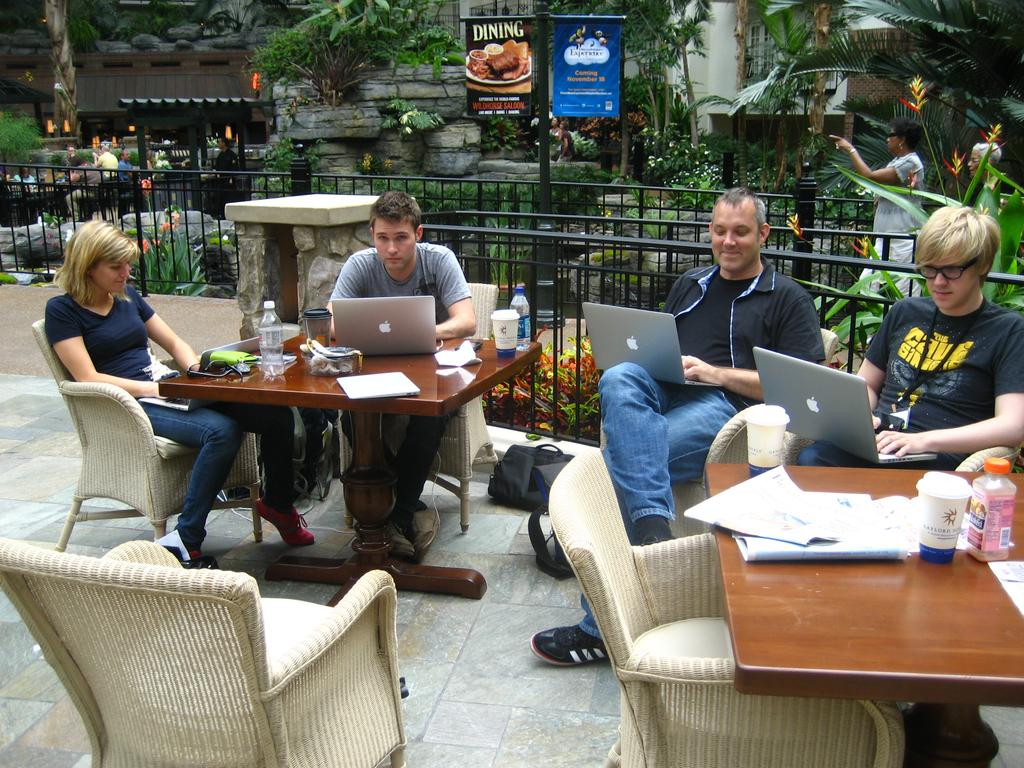How many people are sitting in the image? There are four people sitting on chairs in the image. What objects can be seen on the table? There is a bottle, a book, a cup, and a laptop on the table. What is visible in the background of the image? Trees and a building are visible at the back side of the image. What language are the people speaking in the image? There is no information about the language being spoken in the image. How many friends are present in the image? The term "friends" is not mentioned in the facts provided, so we cannot determine the relationship between the people in the image. 